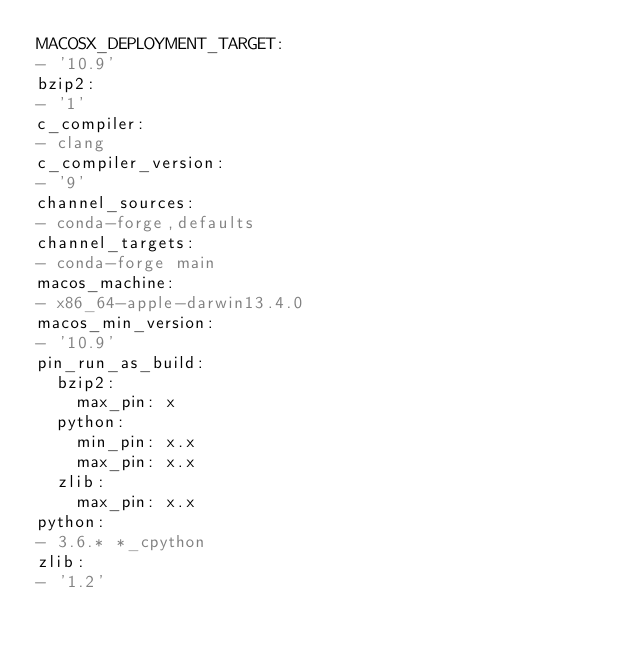Convert code to text. <code><loc_0><loc_0><loc_500><loc_500><_YAML_>MACOSX_DEPLOYMENT_TARGET:
- '10.9'
bzip2:
- '1'
c_compiler:
- clang
c_compiler_version:
- '9'
channel_sources:
- conda-forge,defaults
channel_targets:
- conda-forge main
macos_machine:
- x86_64-apple-darwin13.4.0
macos_min_version:
- '10.9'
pin_run_as_build:
  bzip2:
    max_pin: x
  python:
    min_pin: x.x
    max_pin: x.x
  zlib:
    max_pin: x.x
python:
- 3.6.* *_cpython
zlib:
- '1.2'
</code> 